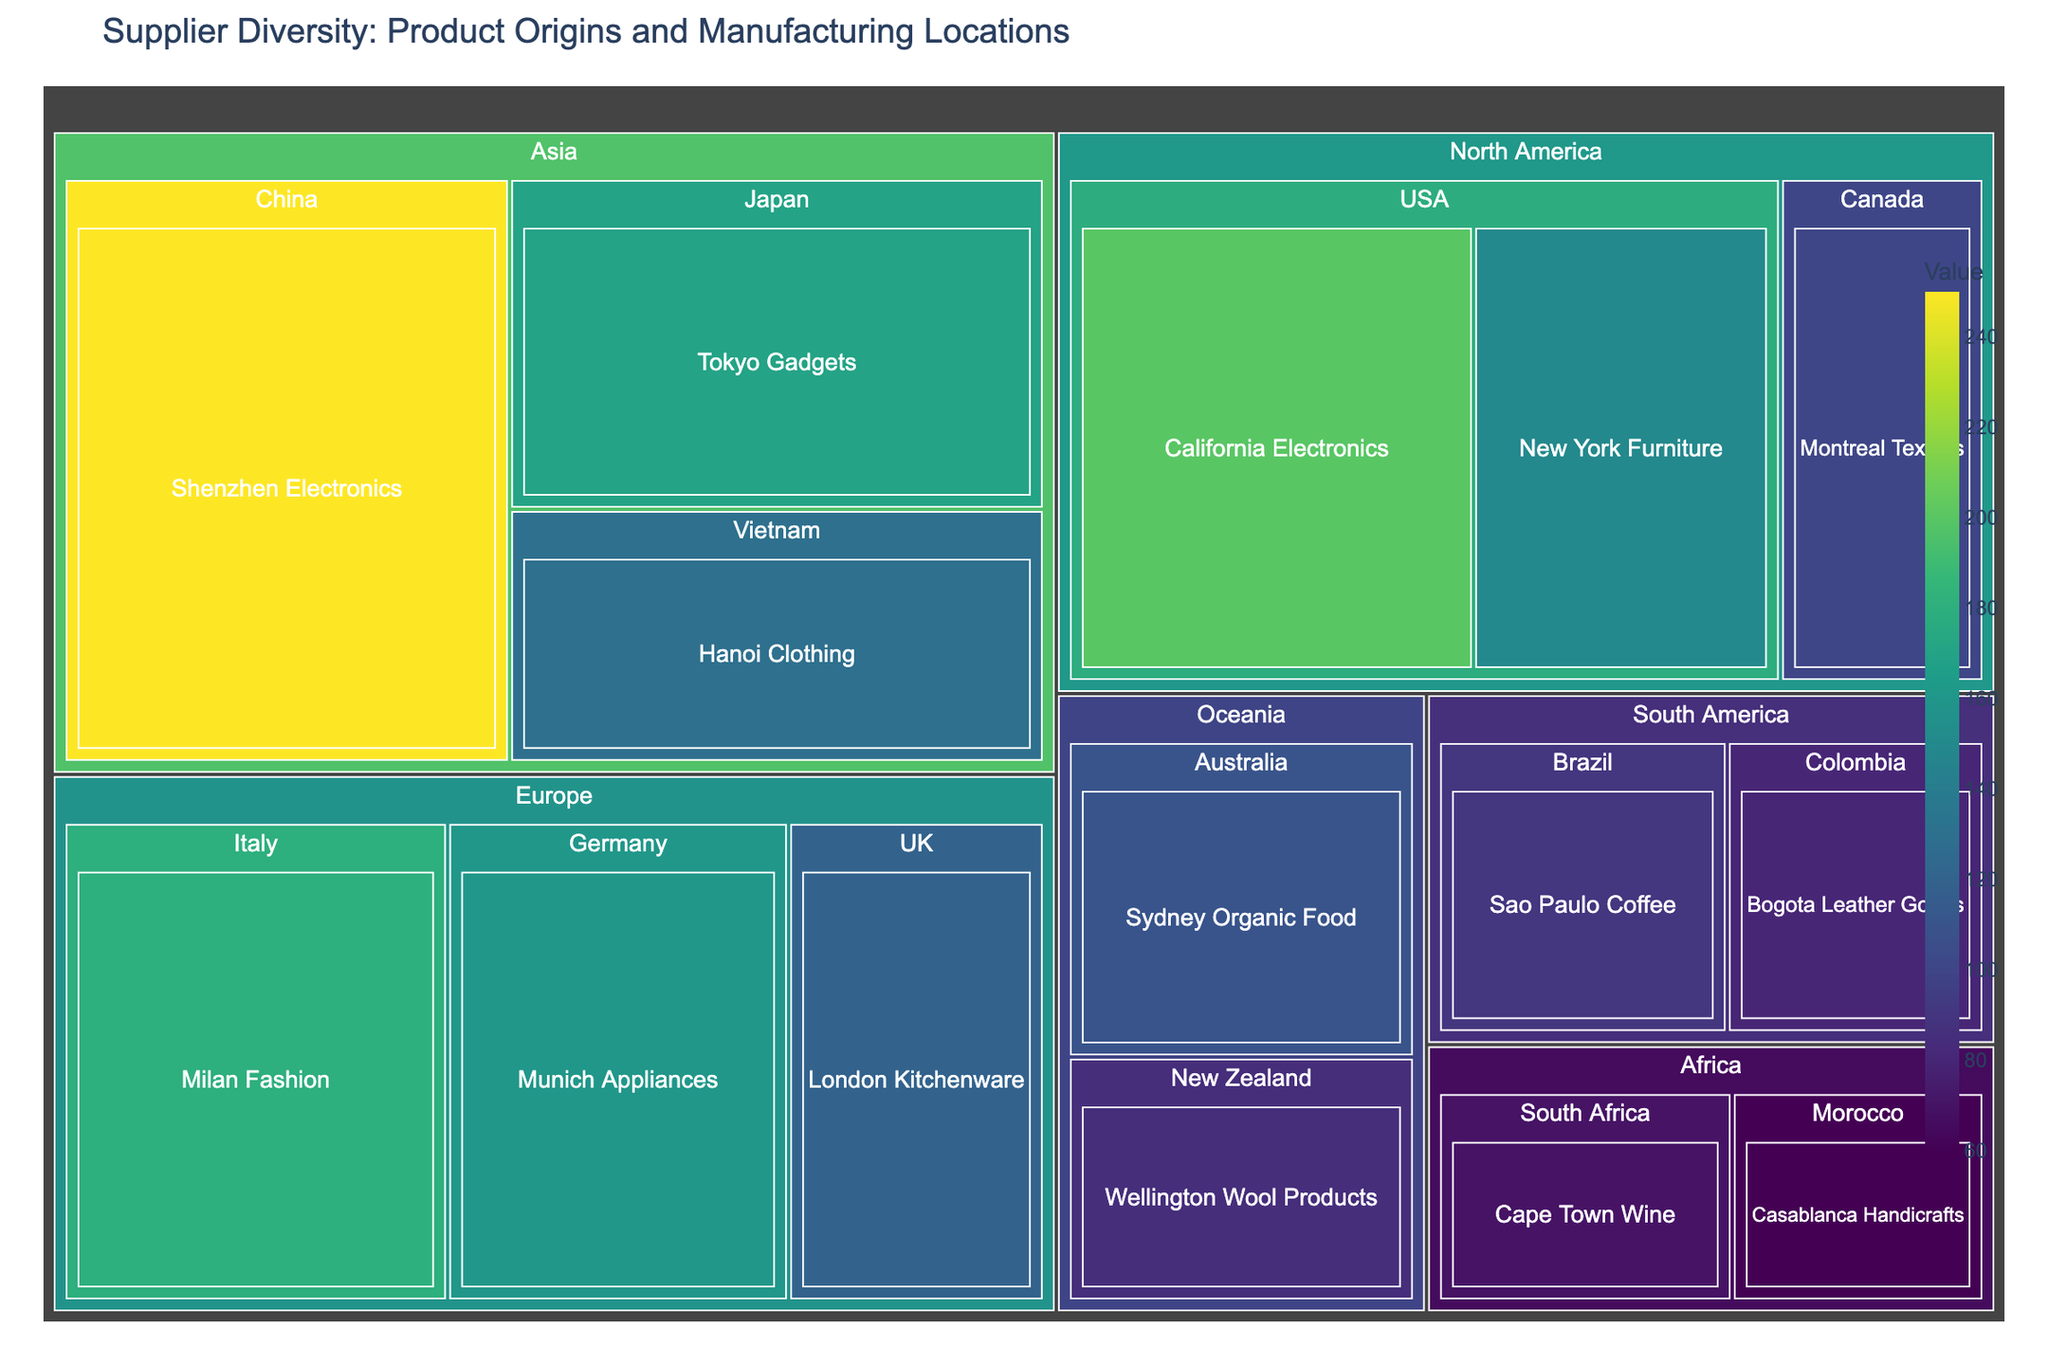What is the title of the treemap? The title is usually displayed at the top of the figure in a larger and bolder font. It indicates the main topic or purpose of the visual, helping viewers understand what the data is about without needing to analyze the entire chart. In this case, the title should be clearly mentioned.
Answer: Supplier Diversity: Product Origins and Manufacturing Locations Which product has the highest value? To determine which product has the highest value, we need to examine the tiles in the treemap and identify the one with the largest area and the darkest color (since color represents value). By scanning through the chart, we can find that "Shenzhen Electronics" from China has the highest value of 250.
Answer: Shenzhen Electronics What is the total value of products from North America? We need to sum the values of all products listed under the North America category. This includes "New York Furniture" (150), "California Electronics" (200), and "Montreal Textiles" (100). We add these numbers together: 150 + 200 + 100 = 450.
Answer: 450 Which region has more product variety, Europe or Asia? Product variety is determined by the number of distinct products. We count the number of products within each region: Europe has "Milan Fashion," "Munich Appliances," and "London Kitchenware" (3 products), while Asia has "Shenzhen Electronics," "Tokyo Gadgets," and "Hanoi Clothing" (3 products). Both regions have the same product variety.
Answer: Equal Which region has the lowest total value of products? We need to calculate the total values for each region and compare them. Africa has "Cape Town Wine" (70) and "Casablanca Handicrafts" (60), total value = 130. South America has "Sao Paulo Coffee" (90) and "Bogota Leather Goods" (80), total value = 170. Oceania has "Sydney Organic Food" (110) and "Wellington Wool Products" (85), total value = 195. Europe, North America, and Asia all have higher totals. Thus, Africa has the lowest total value.
Answer: Africa What is the average value of products from Oceania? To find the average, we sum the values of the products and then divide by the number of products. Oceania has two products: "Sydney Organic Food" (110) and "Wellington Wool Products" (85). The sum is 110 + 85 = 195, and the average is 195 / 2 = 97.5.
Answer: 97.5 In terms of product value, how does "Tokyo Gadgets" compare to "Hanoi Clothing"? To compare the values, we look at the specific values of each product. "Tokyo Gadgets" has a value of 170, while "Hanoi Clothing" has a value of 130. Therefore, "Tokyo Gadgets" has a higher value than "Hanoi Clothing".
Answer: Tokyo Gadgets has a higher value What is the value difference between "Milan Fashion" and "California Electronics"? We find the values of both products, which are 180 for "Milan Fashion" and 200 for "California Electronics". The difference is found by subtracting the smaller value from the larger value: 200 - 180 = 20.
Answer: 20 If we combine the values of all products from South America, how does this compare to the total value from Africa? First, we calculate the total value for each region. South America: "Sao Paulo Coffee" (90) + "Bogota Leather Goods" (80) = 170. Africa: "Cape Town Wine" (70) + "Casablanca Handicrafts" (60) = 130. We then compare these totals: 170 (South America) is greater than 130 (Africa).
Answer: South America has a higher total value 